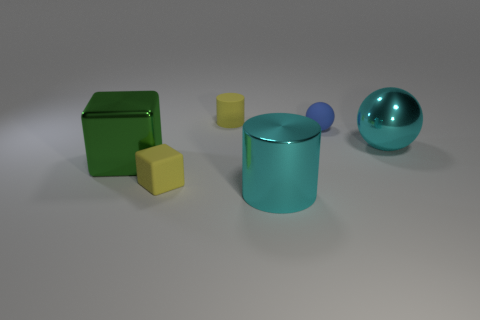Add 1 blue spheres. How many objects exist? 7 Add 3 tiny green rubber cylinders. How many tiny green rubber cylinders exist? 3 Subtract 0 brown balls. How many objects are left? 6 Subtract all cylinders. How many objects are left? 4 Subtract all green objects. Subtract all small blue spheres. How many objects are left? 4 Add 1 rubber things. How many rubber things are left? 4 